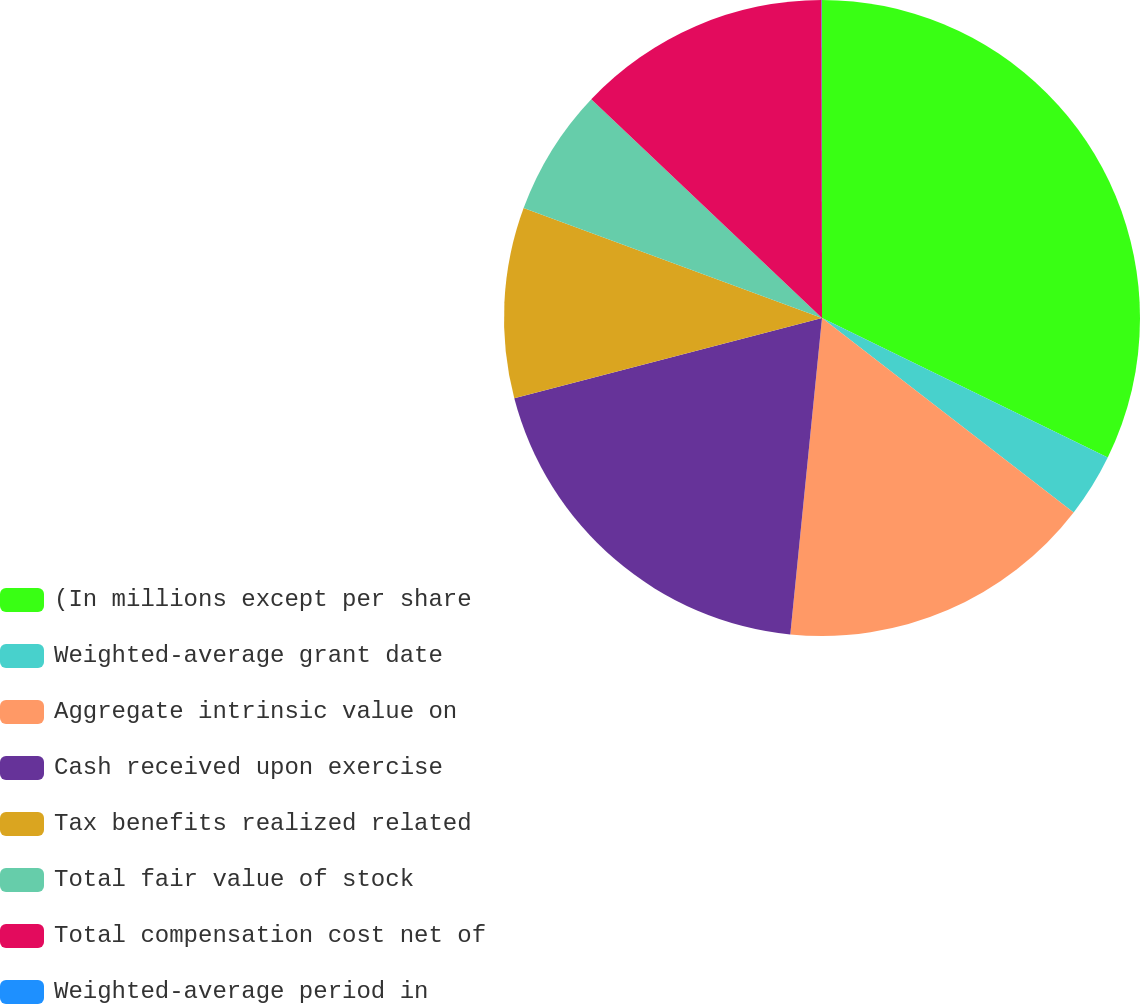Convert chart. <chart><loc_0><loc_0><loc_500><loc_500><pie_chart><fcel>(In millions except per share<fcel>Weighted-average grant date<fcel>Aggregate intrinsic value on<fcel>Cash received upon exercise<fcel>Tax benefits realized related<fcel>Total fair value of stock<fcel>Total compensation cost net of<fcel>Weighted-average period in<nl><fcel>32.23%<fcel>3.24%<fcel>16.12%<fcel>19.35%<fcel>9.68%<fcel>6.46%<fcel>12.9%<fcel>0.02%<nl></chart> 